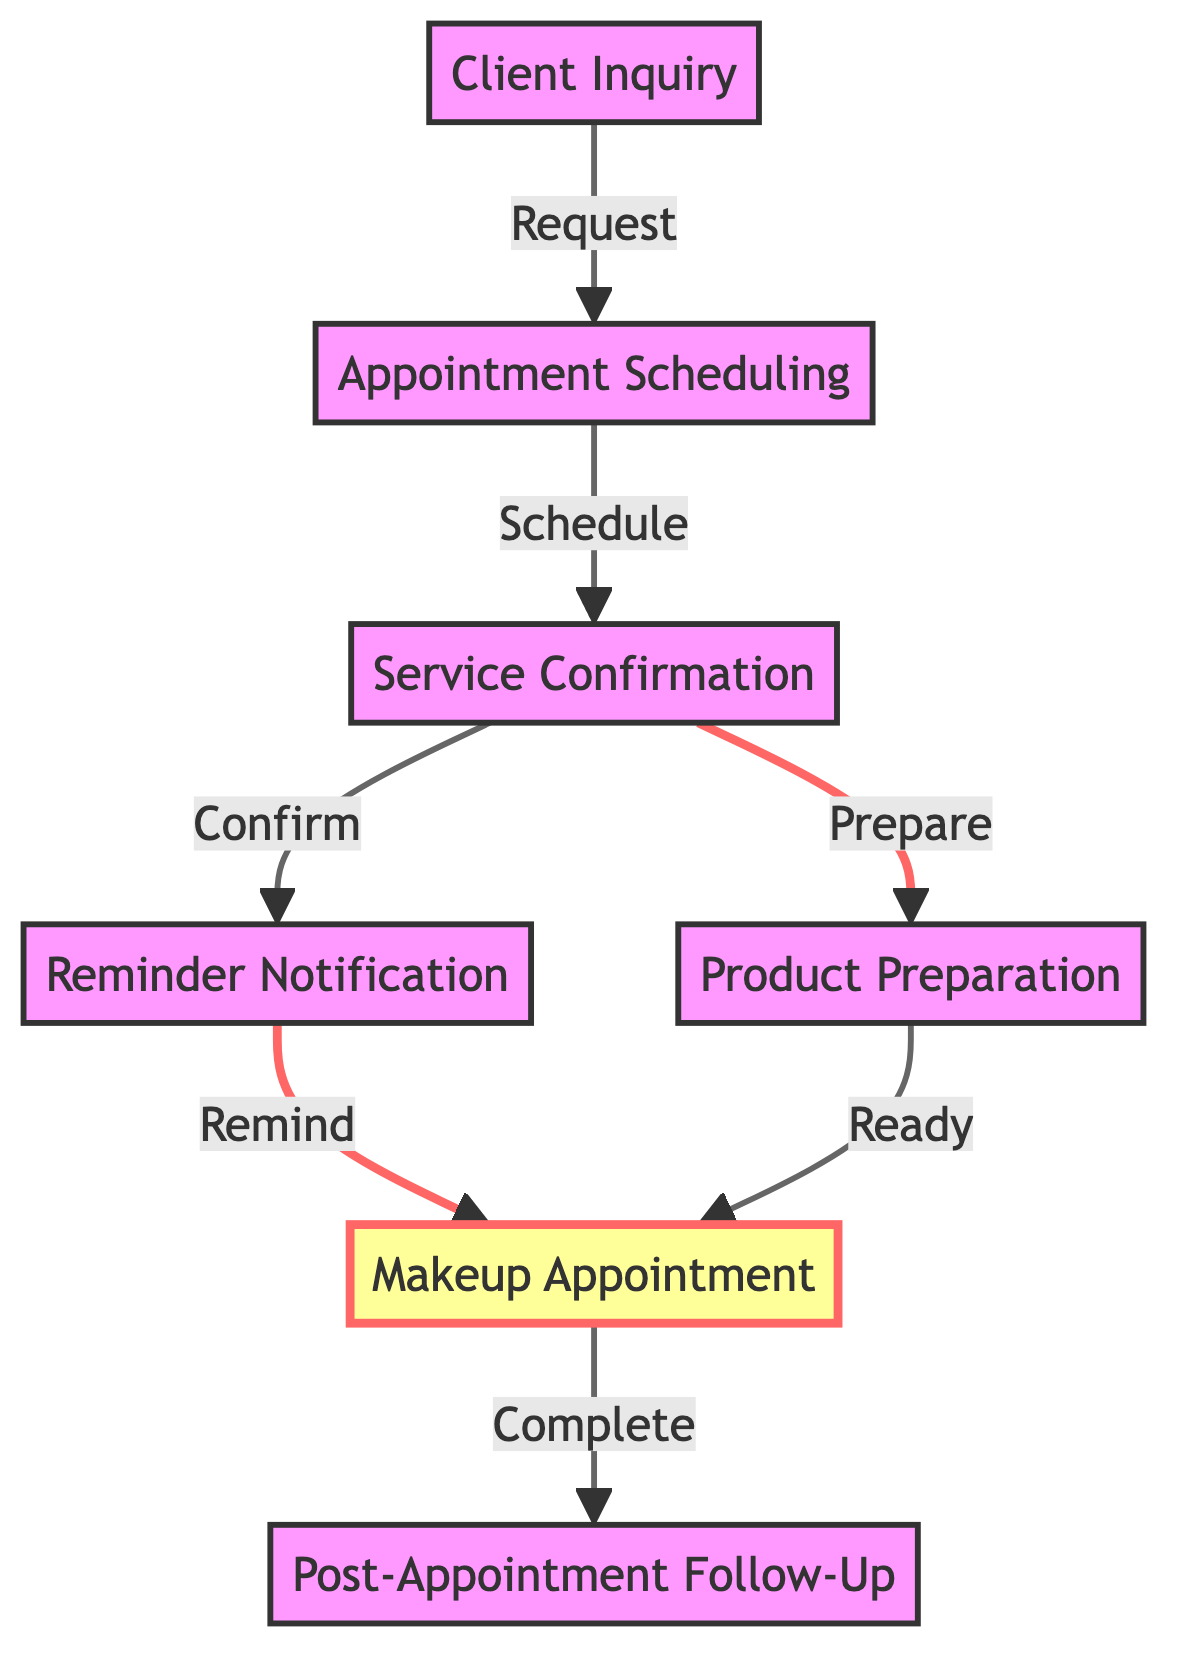What is the first step in the workflow? The first step in the workflow is the "Client Inquiry," which is the initial contact from the client requesting makeup services.
Answer: Client Inquiry How many nodes are in the diagram? The diagram contains seven nodes representing different steps in the makeup appointment workflow: Client Inquiry, Appointment Scheduling, Service Confirmation, Reminder Notification, Product Preparation, Makeup Appointment, and Post-Appointment Follow-Up.
Answer: Seven What follows after the "Service Confirmation"? After "Service Confirmation," the next steps are "Reminder Notification" and "Product Preparation," indicating that both a reminder is sent and products are prepared simultaneously.
Answer: Reminder Notification and Product Preparation Which node directly prepares products? The node responsible for preparing products is "Product Preparation," which involves gathering and preparing the necessary makeup products for the appointment.
Answer: Product Preparation What is the final step in the process? The final step in the process is "Post-Appointment Follow-Up," where the service provider reaches out to the client to gather feedback and encourage future bookings.
Answer: Post-Appointment Follow-Up How are "Reminder Notification" and "Product Preparation" connected to the "Makeup Appointment"? Both "Reminder Notification" and "Product Preparation" lead to the "Makeup Appointment," indicating that the reminder is sent and products are prepared before the appointment takes place.
Answer: They both lead to Makeup Appointment How many edges connect the nodes in the diagram? There are six edges connecting the nodes. These represent the directional connections between the different steps of the workflow, such as from "Client Inquiry" to "Appointment Scheduling."
Answer: Six 